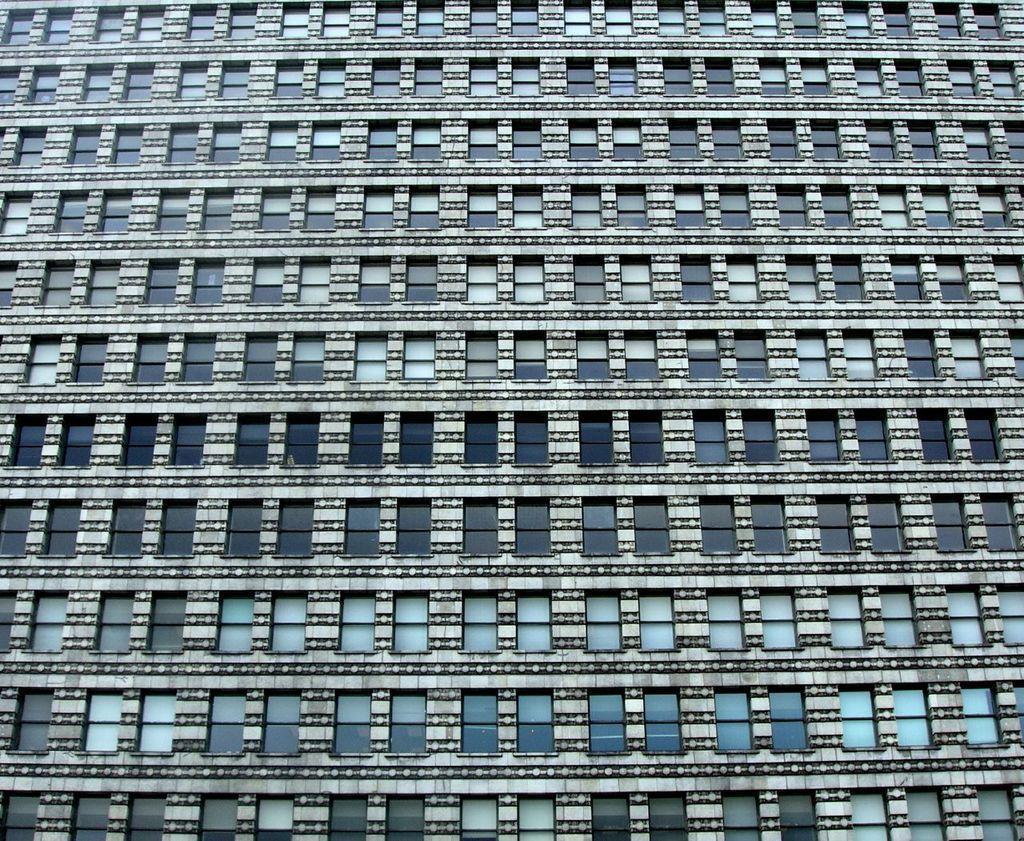How would you summarize this image in a sentence or two? In this image I can see something which looks like a building. I can also see this building has windows. 